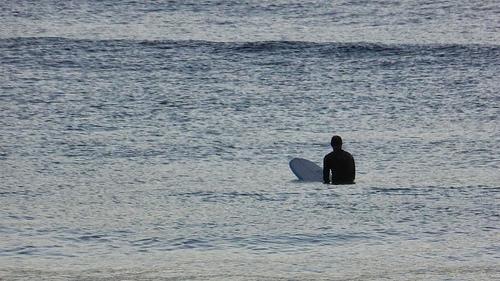How many people are there?
Give a very brief answer. 1. 